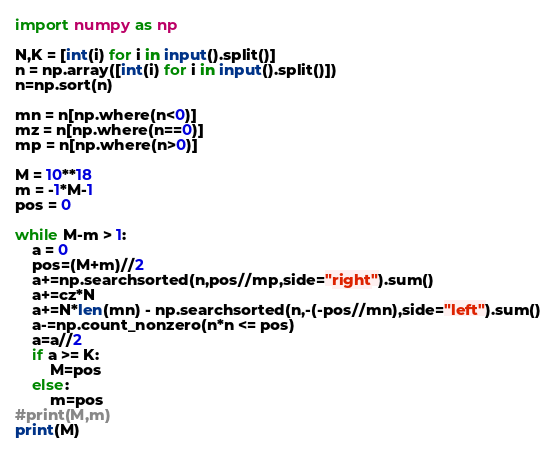<code> <loc_0><loc_0><loc_500><loc_500><_Python_>import numpy as np

N,K = [int(i) for i in input().split()]
n = np.array([int(i) for i in input().split()])
n=np.sort(n)

mn = n[np.where(n<0)]
mz = n[np.where(n==0)]
mp = n[np.where(n>0)]

M = 10**18
m = -1*M-1
pos = 0

while M-m > 1:
    a = 0
    pos=(M+m)//2
    a+=np.searchsorted(n,pos//mp,side="right").sum()
    a+=cz*N
    a+=N*len(mn) - np.searchsorted(n,-(-pos//mn),side="left").sum()
    a-=np.count_nonzero(n*n <= pos)
    a=a//2
    if a >= K:
        M=pos
    else:
        m=pos
#print(M,m)
print(M)
</code> 